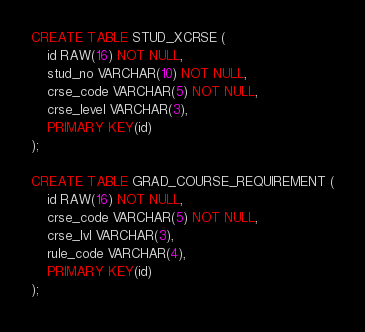<code> <loc_0><loc_0><loc_500><loc_500><_SQL_>CREATE TABLE STUD_XCRSE (
    id RAW(16) NOT NULL,
    stud_no VARCHAR(10) NOT NULL,
    crse_code VARCHAR(5) NOT NULL,
    crse_level VARCHAR(3),
    PRIMARY KEY(id)
);

CREATE TABLE GRAD_COURSE_REQUIREMENT (
    id RAW(16) NOT NULL,
    crse_code VARCHAR(5) NOT NULL,
    crse_lvl VARCHAR(3),
    rule_code VARCHAR(4),
    PRIMARY KEY(id)
);
</code> 